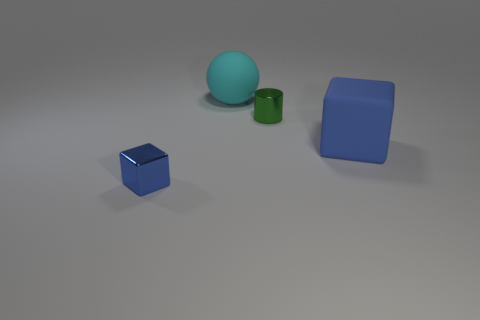What color is the tiny metallic object to the left of the small object behind the blue block that is on the left side of the big cyan object? Upon closer inspection of the image, the tiny metallic object to the left of the small green cylinder behind the blue block (to the left of the large cyan spherical object) appears to be silver. 